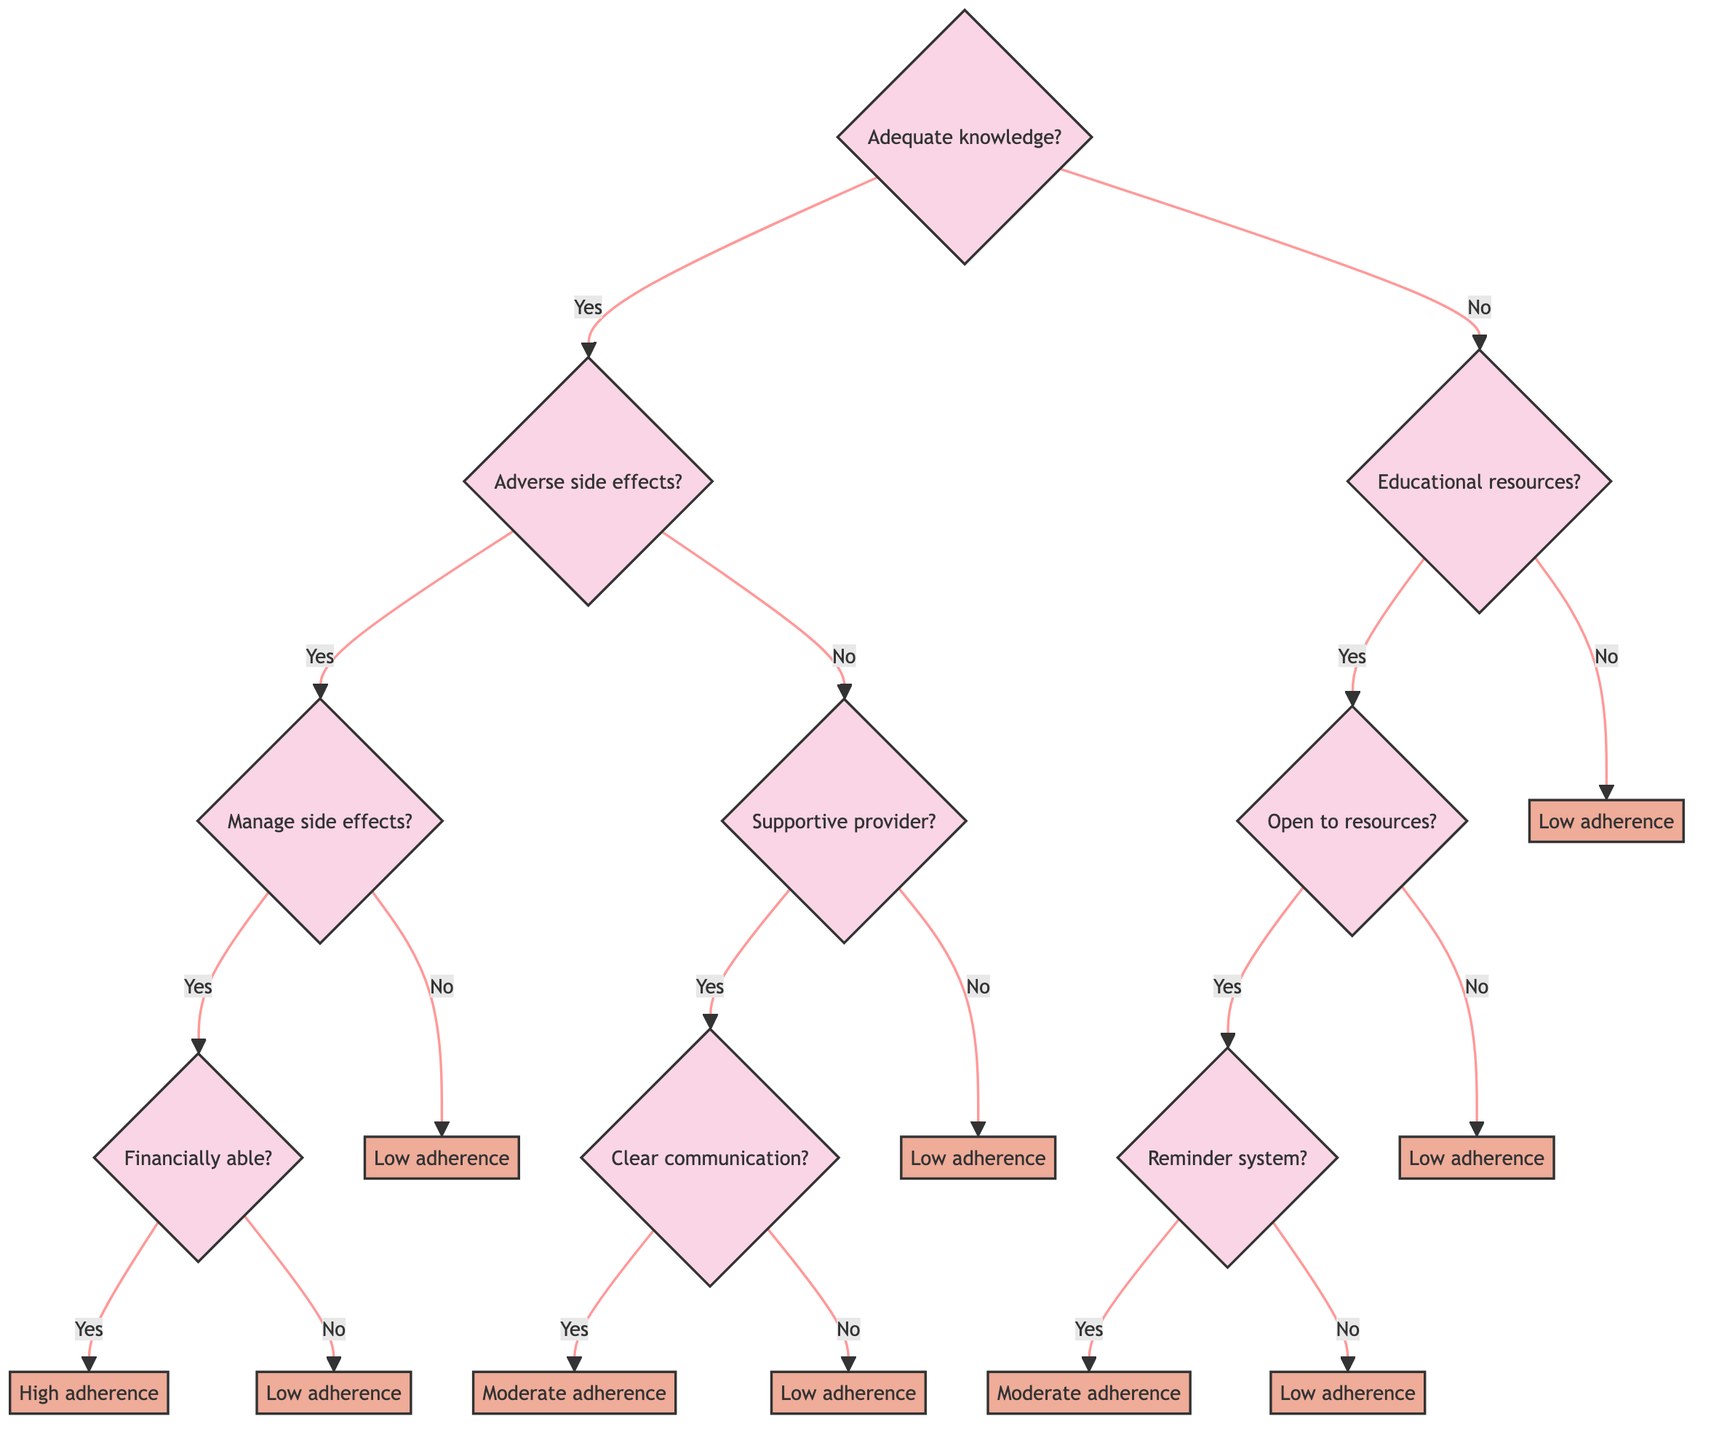What is the first question in the decision tree? The first question in the decision tree is about whether the patient has adequate knowledge about their medication. This is represented as the root node of the diagram.
Answer: Does the patient have adequate knowledge about their medication? What follows if the patient has adequate knowledge and experiences adverse side effects? If a patient has adequate knowledge and is experiencing adverse side effects, the next question asks whether there is a way to manage or mitigate the side effects. This follows the 'yes' branch of the second node.
Answer: Is there a way to manage or mitigate the side effects? How many outcome decisions are there in this decision tree? To find the number of outcome decisions, we can count the terminal nodes in the diagram. The possible outcomes are: high likelihood of medication adherence, moderate likelihood of medication adherence, and low likelihood of medication adherence. Thus, there are three distinct outcomes.
Answer: Three What happens when a patient has inadequate knowledge and is open to educational resources? If a patient does not have adequate knowledge but is open to educational resources, the next question asks if the patient has a reminder system or support network. This signifies a progression along the 'yes' branch after checking the availability of educational resources.
Answer: Does the patient have a reminder system or support network? What is the likelihood of medication adherence if the patient cannot financially afford the medication but can manage the side effects? In this scenario, the flow leads to a point where the patient cannot afford the medication after confirming the management of side effects. Hence, the decision is that there is a low likelihood of medication adherence.
Answer: Low likelihood of medication adherence 